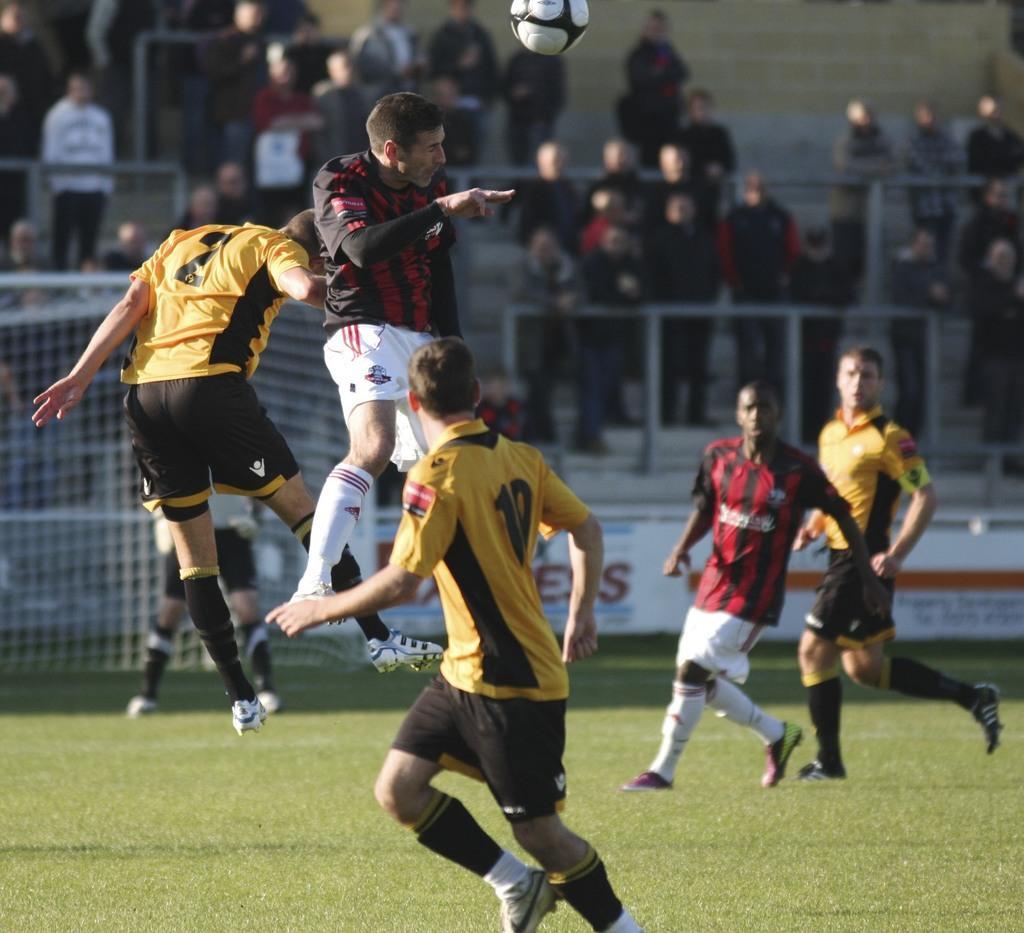In one or two sentences, can you explain what this image depicts? This is a playing ground. Here I can see few men wearing t-shirts, shorts and playing the football. In the background there is a net and many people are standing and looking at the ground. 